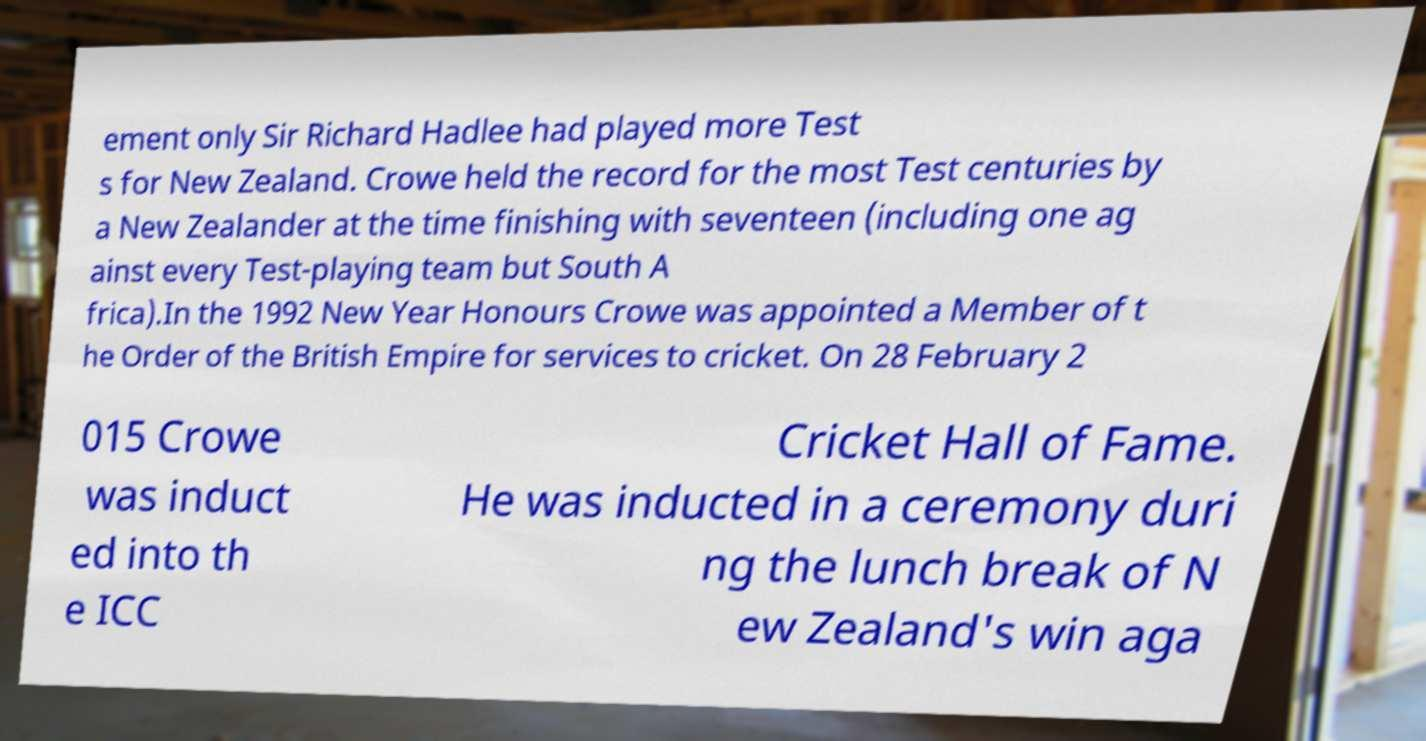What messages or text are displayed in this image? I need them in a readable, typed format. ement only Sir Richard Hadlee had played more Test s for New Zealand. Crowe held the record for the most Test centuries by a New Zealander at the time finishing with seventeen (including one ag ainst every Test-playing team but South A frica).In the 1992 New Year Honours Crowe was appointed a Member of t he Order of the British Empire for services to cricket. On 28 February 2 015 Crowe was induct ed into th e ICC Cricket Hall of Fame. He was inducted in a ceremony duri ng the lunch break of N ew Zealand's win aga 